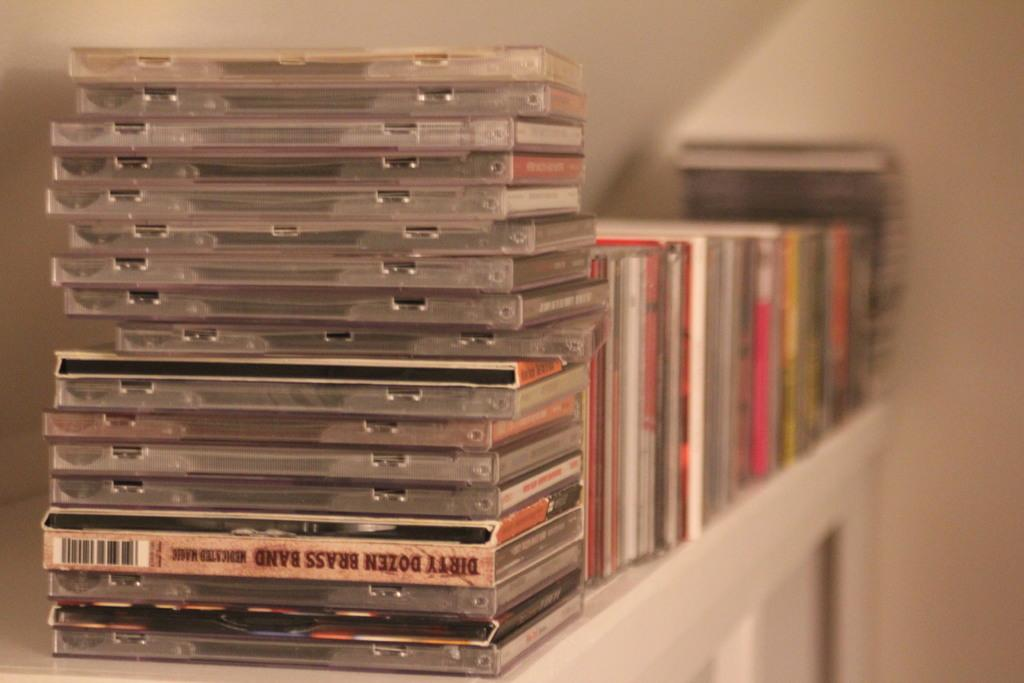Provide a one-sentence caption for the provided image. A stack of music cds includes one by the Dirty Dozen Brass Band. 